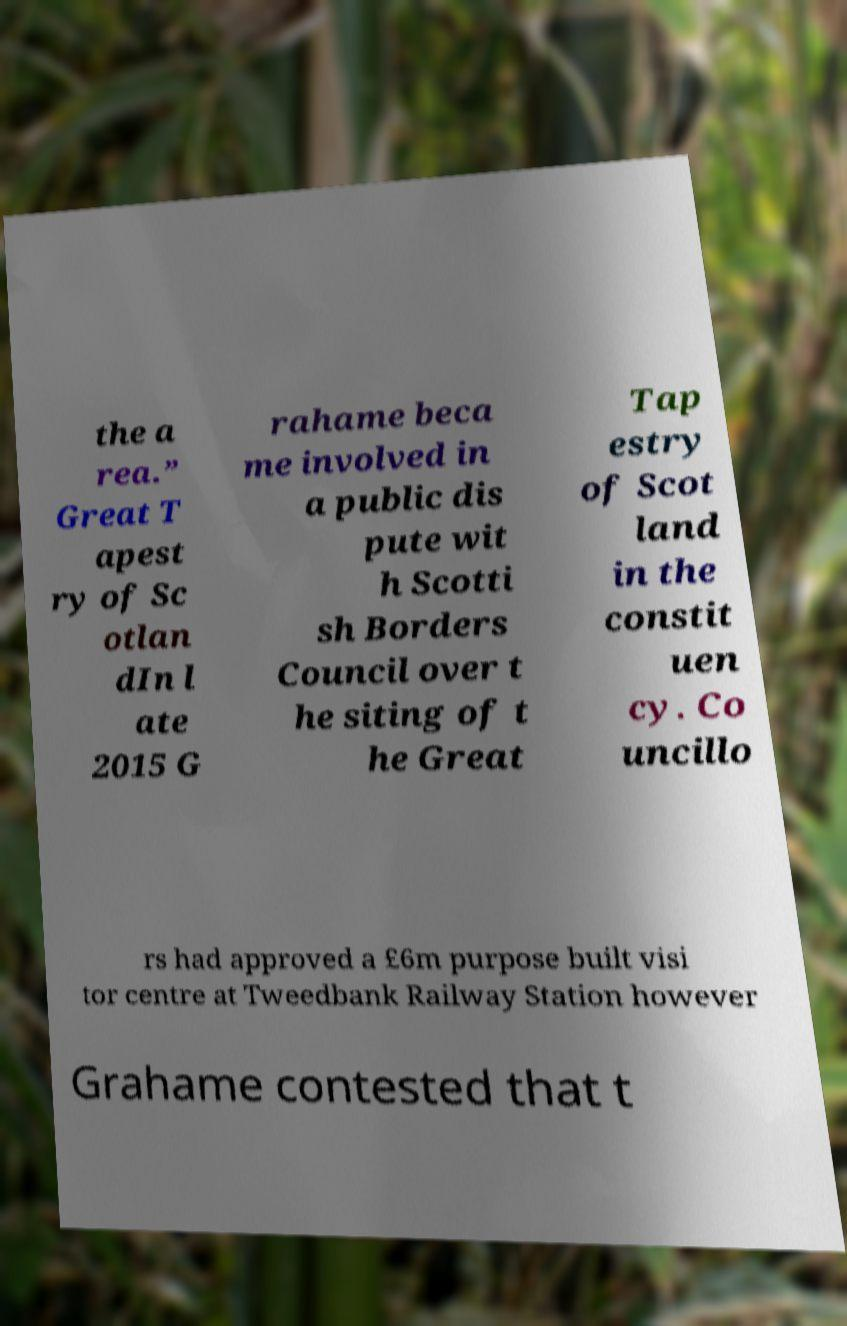For documentation purposes, I need the text within this image transcribed. Could you provide that? the a rea.” Great T apest ry of Sc otlan dIn l ate 2015 G rahame beca me involved in a public dis pute wit h Scotti sh Borders Council over t he siting of t he Great Tap estry of Scot land in the constit uen cy. Co uncillo rs had approved a £6m purpose built visi tor centre at Tweedbank Railway Station however Grahame contested that t 